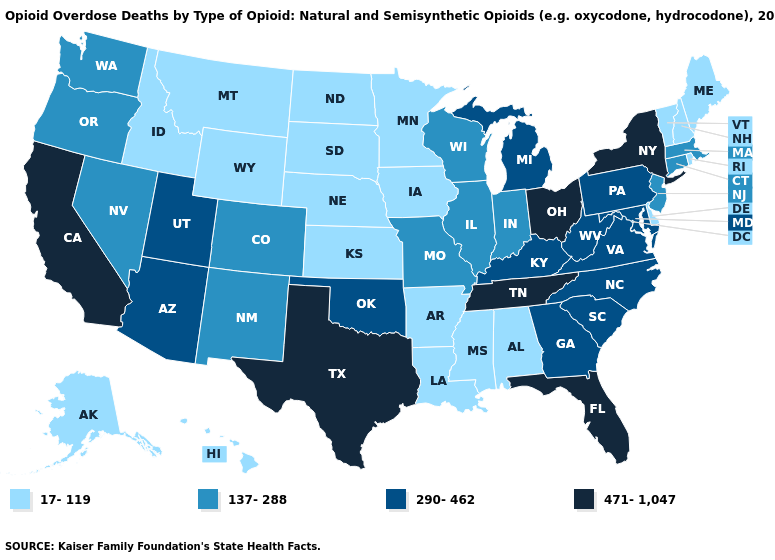Which states have the lowest value in the Northeast?
Short answer required. Maine, New Hampshire, Rhode Island, Vermont. Among the states that border Connecticut , which have the highest value?
Give a very brief answer. New York. What is the lowest value in the Northeast?
Keep it brief. 17-119. What is the value of Kentucky?
Answer briefly. 290-462. What is the highest value in states that border Maryland?
Concise answer only. 290-462. Name the states that have a value in the range 290-462?
Write a very short answer. Arizona, Georgia, Kentucky, Maryland, Michigan, North Carolina, Oklahoma, Pennsylvania, South Carolina, Utah, Virginia, West Virginia. Is the legend a continuous bar?
Keep it brief. No. Among the states that border Vermont , which have the highest value?
Write a very short answer. New York. Name the states that have a value in the range 17-119?
Answer briefly. Alabama, Alaska, Arkansas, Delaware, Hawaii, Idaho, Iowa, Kansas, Louisiana, Maine, Minnesota, Mississippi, Montana, Nebraska, New Hampshire, North Dakota, Rhode Island, South Dakota, Vermont, Wyoming. What is the lowest value in the MidWest?
Concise answer only. 17-119. Does the first symbol in the legend represent the smallest category?
Keep it brief. Yes. Does New Jersey have the same value as Idaho?
Concise answer only. No. Name the states that have a value in the range 137-288?
Be succinct. Colorado, Connecticut, Illinois, Indiana, Massachusetts, Missouri, Nevada, New Jersey, New Mexico, Oregon, Washington, Wisconsin. Does the map have missing data?
Write a very short answer. No. What is the value of Delaware?
Be succinct. 17-119. 